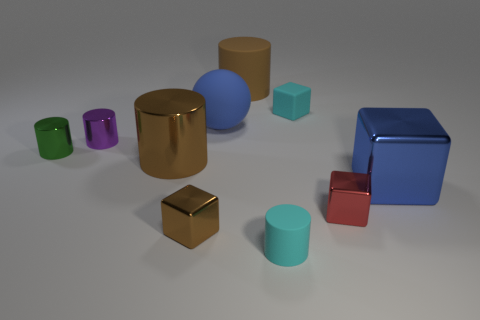Are there more small red things than green matte balls?
Your answer should be very brief. Yes. Does the large brown thing that is right of the brown cube have the same material as the cube that is on the right side of the red cube?
Offer a very short reply. No. What material is the blue ball?
Ensure brevity in your answer.  Rubber. Is the number of brown rubber cylinders on the left side of the small cyan cylinder greater than the number of large gray cylinders?
Give a very brief answer. Yes. How many rubber cylinders are behind the big thing in front of the brown cylinder in front of the big brown rubber thing?
Your response must be concise. 1. What is the tiny block that is in front of the brown metallic cylinder and behind the brown block made of?
Your answer should be very brief. Metal. What color is the big ball?
Your response must be concise. Blue. Is the number of big cylinders left of the tiny brown metallic cube greater than the number of blue metallic things to the left of the big brown shiny thing?
Provide a succinct answer. Yes. There is a matte cylinder in front of the large brown rubber thing; what color is it?
Your answer should be very brief. Cyan. There is a brown cylinder that is in front of the large blue rubber ball; is its size the same as the cube on the left side of the cyan cube?
Your answer should be compact. No. 